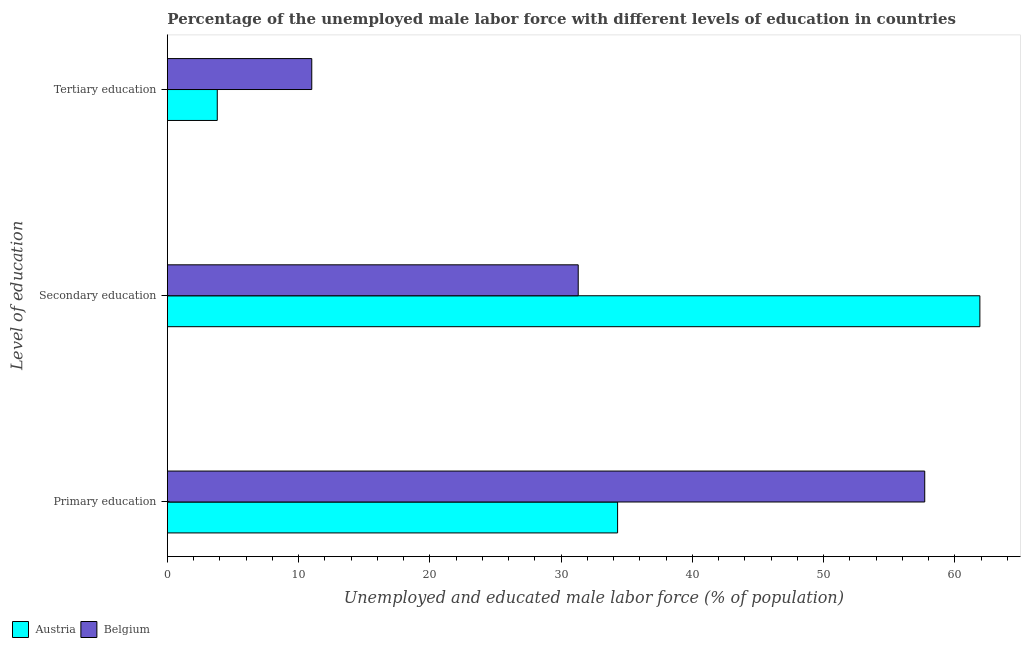What is the label of the 2nd group of bars from the top?
Provide a short and direct response. Secondary education. What is the percentage of male labor force who received primary education in Austria?
Give a very brief answer. 34.3. Across all countries, what is the maximum percentage of male labor force who received primary education?
Your response must be concise. 57.7. Across all countries, what is the minimum percentage of male labor force who received tertiary education?
Your answer should be very brief. 3.8. In which country was the percentage of male labor force who received primary education minimum?
Keep it short and to the point. Austria. What is the total percentage of male labor force who received primary education in the graph?
Provide a succinct answer. 92. What is the difference between the percentage of male labor force who received primary education in Austria and that in Belgium?
Make the answer very short. -23.4. What is the difference between the percentage of male labor force who received tertiary education in Austria and the percentage of male labor force who received primary education in Belgium?
Provide a short and direct response. -53.9. What is the average percentage of male labor force who received tertiary education per country?
Keep it short and to the point. 7.4. What is the difference between the percentage of male labor force who received secondary education and percentage of male labor force who received primary education in Belgium?
Your answer should be very brief. -26.4. What is the ratio of the percentage of male labor force who received secondary education in Austria to that in Belgium?
Your answer should be very brief. 1.98. Is the percentage of male labor force who received primary education in Austria less than that in Belgium?
Your response must be concise. Yes. Is the difference between the percentage of male labor force who received secondary education in Belgium and Austria greater than the difference between the percentage of male labor force who received primary education in Belgium and Austria?
Offer a very short reply. No. What is the difference between the highest and the second highest percentage of male labor force who received tertiary education?
Offer a terse response. 7.2. What is the difference between the highest and the lowest percentage of male labor force who received tertiary education?
Offer a very short reply. 7.2. Is the sum of the percentage of male labor force who received primary education in Austria and Belgium greater than the maximum percentage of male labor force who received secondary education across all countries?
Give a very brief answer. Yes. How many bars are there?
Your answer should be very brief. 6. Are all the bars in the graph horizontal?
Your response must be concise. Yes. How many countries are there in the graph?
Make the answer very short. 2. What is the difference between two consecutive major ticks on the X-axis?
Your answer should be very brief. 10. Are the values on the major ticks of X-axis written in scientific E-notation?
Offer a terse response. No. Does the graph contain any zero values?
Give a very brief answer. No. Where does the legend appear in the graph?
Keep it short and to the point. Bottom left. How are the legend labels stacked?
Provide a short and direct response. Horizontal. What is the title of the graph?
Provide a succinct answer. Percentage of the unemployed male labor force with different levels of education in countries. What is the label or title of the X-axis?
Offer a terse response. Unemployed and educated male labor force (% of population). What is the label or title of the Y-axis?
Your answer should be very brief. Level of education. What is the Unemployed and educated male labor force (% of population) in Austria in Primary education?
Ensure brevity in your answer.  34.3. What is the Unemployed and educated male labor force (% of population) of Belgium in Primary education?
Your answer should be very brief. 57.7. What is the Unemployed and educated male labor force (% of population) in Austria in Secondary education?
Ensure brevity in your answer.  61.9. What is the Unemployed and educated male labor force (% of population) of Belgium in Secondary education?
Make the answer very short. 31.3. What is the Unemployed and educated male labor force (% of population) of Austria in Tertiary education?
Your answer should be very brief. 3.8. Across all Level of education, what is the maximum Unemployed and educated male labor force (% of population) in Austria?
Give a very brief answer. 61.9. Across all Level of education, what is the maximum Unemployed and educated male labor force (% of population) of Belgium?
Your response must be concise. 57.7. Across all Level of education, what is the minimum Unemployed and educated male labor force (% of population) in Austria?
Your answer should be compact. 3.8. What is the difference between the Unemployed and educated male labor force (% of population) of Austria in Primary education and that in Secondary education?
Give a very brief answer. -27.6. What is the difference between the Unemployed and educated male labor force (% of population) of Belgium in Primary education and that in Secondary education?
Your response must be concise. 26.4. What is the difference between the Unemployed and educated male labor force (% of population) of Austria in Primary education and that in Tertiary education?
Your response must be concise. 30.5. What is the difference between the Unemployed and educated male labor force (% of population) in Belgium in Primary education and that in Tertiary education?
Give a very brief answer. 46.7. What is the difference between the Unemployed and educated male labor force (% of population) in Austria in Secondary education and that in Tertiary education?
Make the answer very short. 58.1. What is the difference between the Unemployed and educated male labor force (% of population) in Belgium in Secondary education and that in Tertiary education?
Offer a terse response. 20.3. What is the difference between the Unemployed and educated male labor force (% of population) in Austria in Primary education and the Unemployed and educated male labor force (% of population) in Belgium in Tertiary education?
Keep it short and to the point. 23.3. What is the difference between the Unemployed and educated male labor force (% of population) of Austria in Secondary education and the Unemployed and educated male labor force (% of population) of Belgium in Tertiary education?
Keep it short and to the point. 50.9. What is the average Unemployed and educated male labor force (% of population) of Austria per Level of education?
Offer a very short reply. 33.33. What is the average Unemployed and educated male labor force (% of population) in Belgium per Level of education?
Your response must be concise. 33.33. What is the difference between the Unemployed and educated male labor force (% of population) in Austria and Unemployed and educated male labor force (% of population) in Belgium in Primary education?
Offer a terse response. -23.4. What is the difference between the Unemployed and educated male labor force (% of population) of Austria and Unemployed and educated male labor force (% of population) of Belgium in Secondary education?
Your answer should be compact. 30.6. What is the ratio of the Unemployed and educated male labor force (% of population) of Austria in Primary education to that in Secondary education?
Your answer should be very brief. 0.55. What is the ratio of the Unemployed and educated male labor force (% of population) of Belgium in Primary education to that in Secondary education?
Give a very brief answer. 1.84. What is the ratio of the Unemployed and educated male labor force (% of population) in Austria in Primary education to that in Tertiary education?
Offer a very short reply. 9.03. What is the ratio of the Unemployed and educated male labor force (% of population) in Belgium in Primary education to that in Tertiary education?
Provide a short and direct response. 5.25. What is the ratio of the Unemployed and educated male labor force (% of population) of Austria in Secondary education to that in Tertiary education?
Your answer should be compact. 16.29. What is the ratio of the Unemployed and educated male labor force (% of population) in Belgium in Secondary education to that in Tertiary education?
Give a very brief answer. 2.85. What is the difference between the highest and the second highest Unemployed and educated male labor force (% of population) in Austria?
Offer a terse response. 27.6. What is the difference between the highest and the second highest Unemployed and educated male labor force (% of population) of Belgium?
Ensure brevity in your answer.  26.4. What is the difference between the highest and the lowest Unemployed and educated male labor force (% of population) in Austria?
Give a very brief answer. 58.1. What is the difference between the highest and the lowest Unemployed and educated male labor force (% of population) in Belgium?
Your answer should be compact. 46.7. 